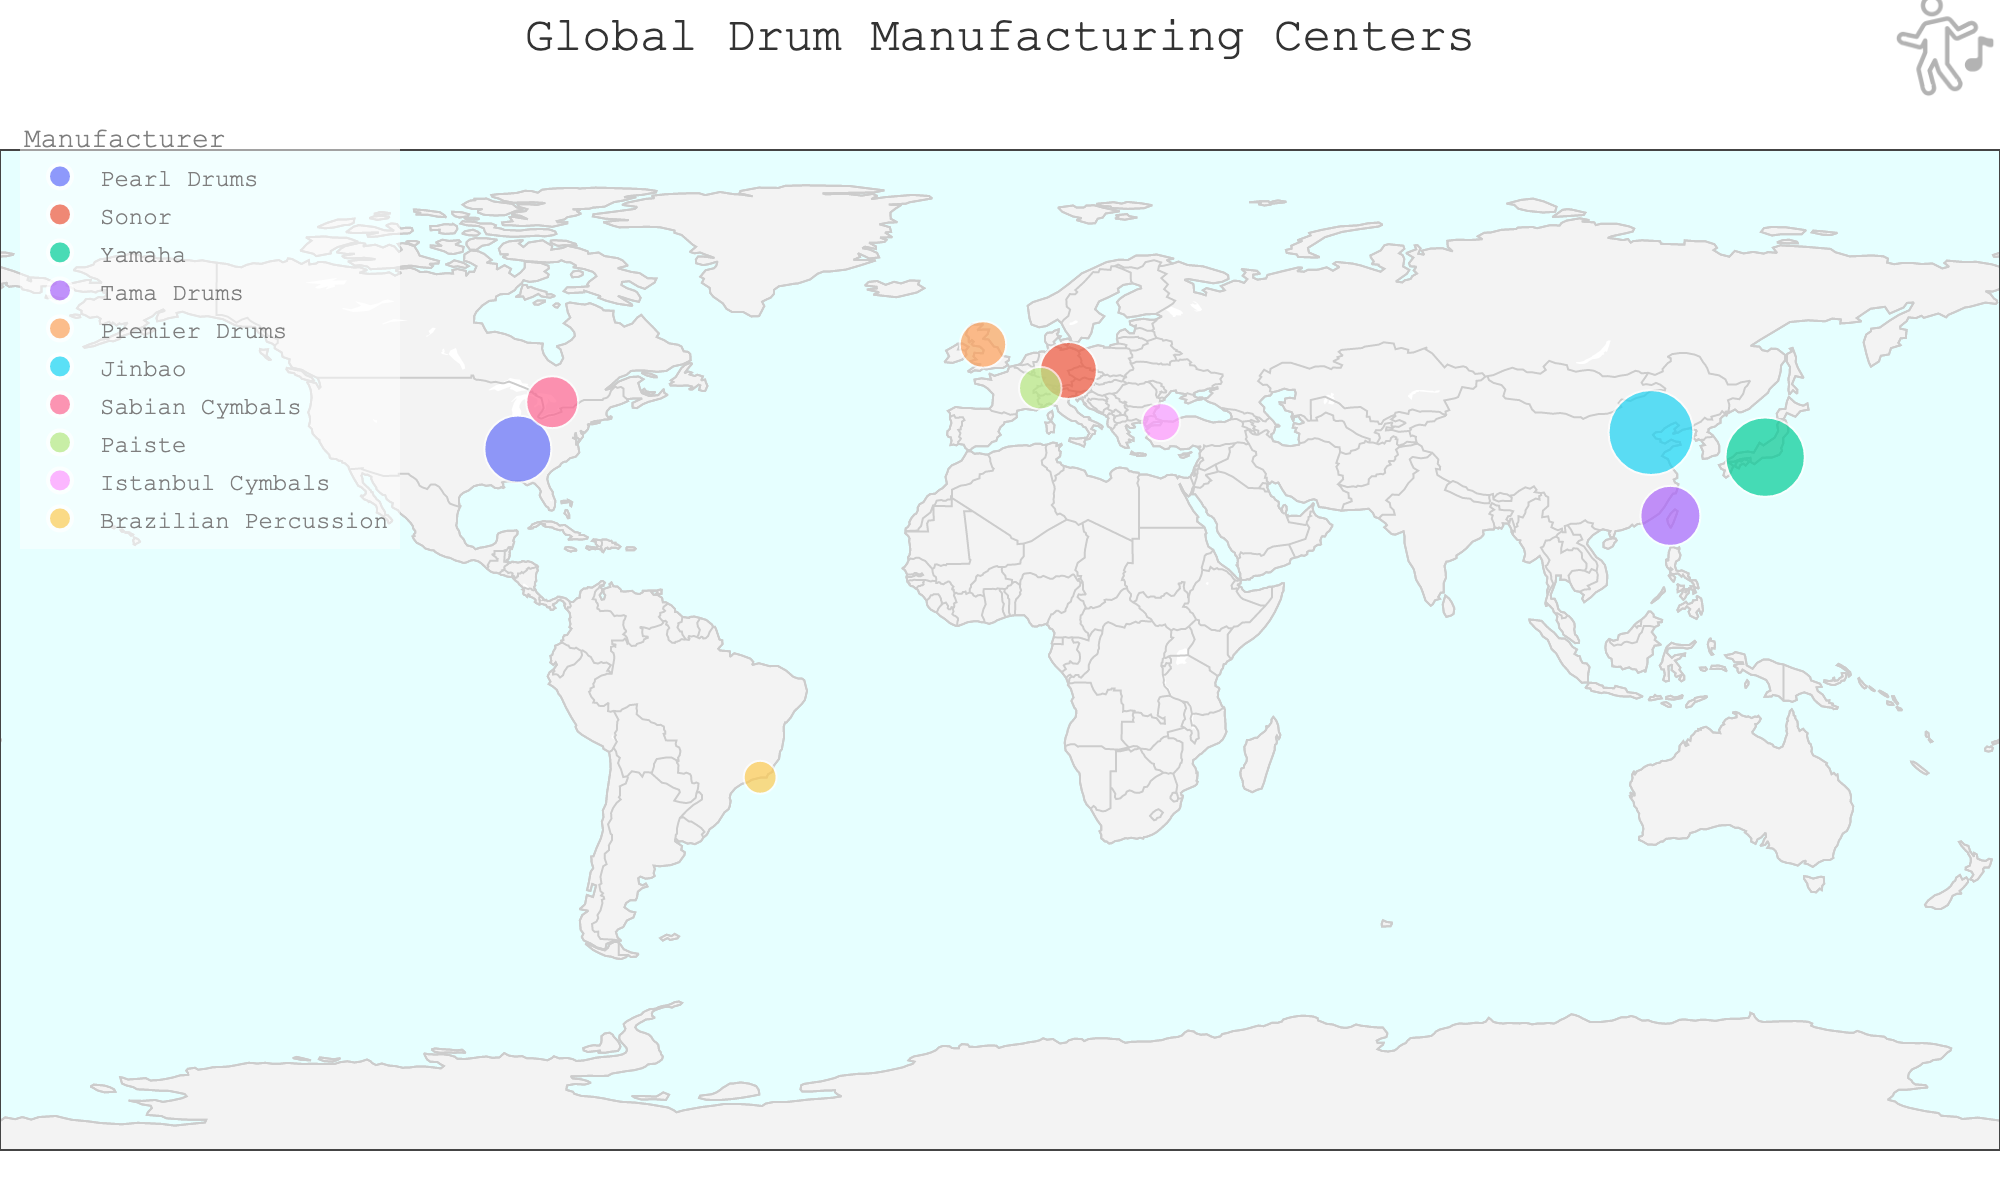what is the title of the figure? The title is usually displayed at the top of the figure and provides a concise description of what the figure represents. In this case, the title "Global Drum Manufacturing Centers" indicates that the figure shows the various locations of drum manufacturers around the world.
Answer: Global Drum Manufacturing Centers How many countries are represented on the map? To find the number of countries represented, count the distinct countries listed in the hover data seen on the map. There are markers for drum manufacturing centers in specific cities, each from different countries.
Answer: 10 Which city has the highest drum production volume, and what is its production? By observing the sizes of the markers, the largest marker indicates the highest production volume. By hovering over the points, we can see the production numbers. The largest marker is in Tianjin, China, representing Jinbao with an annual production of 400,000 drums.
Answer: Tianjin, 400,000 How does the production volume of Pearl Drums in Nashville compare to Yamaha in Hamamatsu? Locate Nashville and Hamamatsu on the map and compare the sizes of the markers. Hovering over them reveals their production volumes: Pearl Drums in Nashville has 250,000 units and Yamaha in Hamamatsu has 350,000 units. Therefore, Yamaha in Hamamatsu has a higher production volume.
Answer: Yamaha in Hamamatsu has a higher production volume Which manufacturer is located furthest south? Look at the latitude coordinates of each city's location to determine which one is furthest south. The city with the lowest latitude (most negative value) is Rio de Janeiro, Brazil, where Brazilian Percussion is located.
Answer: Brazilian Percussion in Rio de Janeiro What is the average annual production across all manufacturers shown in the figure? To find the average production, sum the annual production volumes of all manufacturers and divide by the number of manufacturers. The total production is (250,000 + 180,000 + 350,000 + 200,000 + 120,000 + 400,000 + 150,000 + 100,000 + 80,000 + 60,000) = 1,890,000 units. There are 10 manufacturers, so the average is 1,890,000 / 10 = 189,000 units.
Answer: 189,000 units Which two cities have the closest production volumes, and what are those volumes? By comparing the annual production volumes of each city, we find that Nashville (250,000 units) and Taichung (200,000 units) have the closest production volumes. Their difference is 50,000 units.
Answer: Nashville (250,000) and Taichung (200,000) Are there more drum manufacturing centers in Asia or in Europe as shown in the figure? Identify the continents of each city from the figure. In Asia, we have Hamamatsu (Japan), Taichung (Taiwan), Tianjin (China), and Istanbul (Turkey) - 4 cities. In Europe, we have Markneukirchen (Germany), Gretna (UK), and Biel (Switzerland) - 3 cities.
Answer: Asia has more manufacturing centers What is the total production volume for all manufacturers located in Europe? Sum the annual production volumes of all manufacturers located in Europe: Sonor in Markneukirchen (180,000), Premier Drums in Gretna (120,000), and Paiste in Biel (100,000). The total is 180,000 + 120,000 + 100,000 = 400,000 units.
Answer: 400,000 units Which city has the smallest drum production, and what is its volume? The smallest marker on the map represents the location with the smallest drum production. Hover over the smallest marker to find the city and production volume. Rio de Janeiro, Brazil, representing Brazilian Percussion has the smallest production of 60,000 units.
Answer: Rio de Janeiro, 60,000 units 